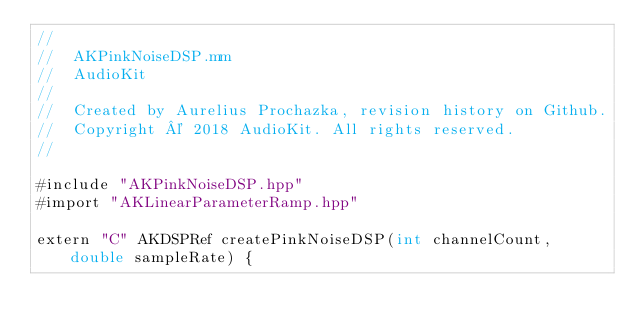Convert code to text. <code><loc_0><loc_0><loc_500><loc_500><_ObjectiveC_>//
//  AKPinkNoiseDSP.mm
//  AudioKit
//
//  Created by Aurelius Prochazka, revision history on Github.
//  Copyright © 2018 AudioKit. All rights reserved.
//

#include "AKPinkNoiseDSP.hpp"
#import "AKLinearParameterRamp.hpp"

extern "C" AKDSPRef createPinkNoiseDSP(int channelCount, double sampleRate) {</code> 